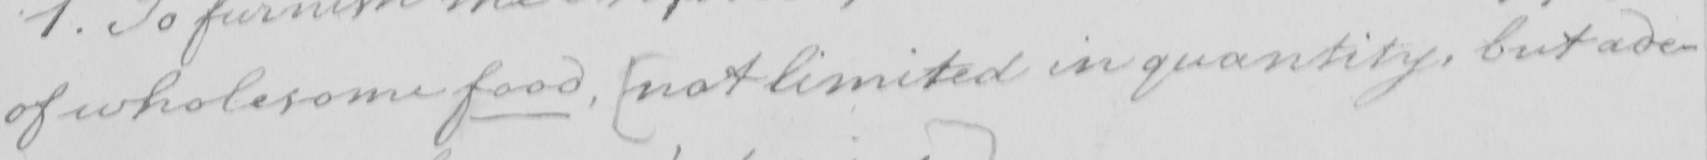Please provide the text content of this handwritten line. of wholesome food ,  [ not limited in quantity , but ade- 